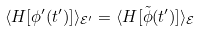<formula> <loc_0><loc_0><loc_500><loc_500>\langle H [ \phi ^ { \prime } ( t ^ { \prime } ) ] \rangle _ { \mathcal { E } ^ { \prime } } = \langle H [ \tilde { \phi } ( t ^ { \prime } ) ] \rangle _ { \mathcal { E } }</formula> 